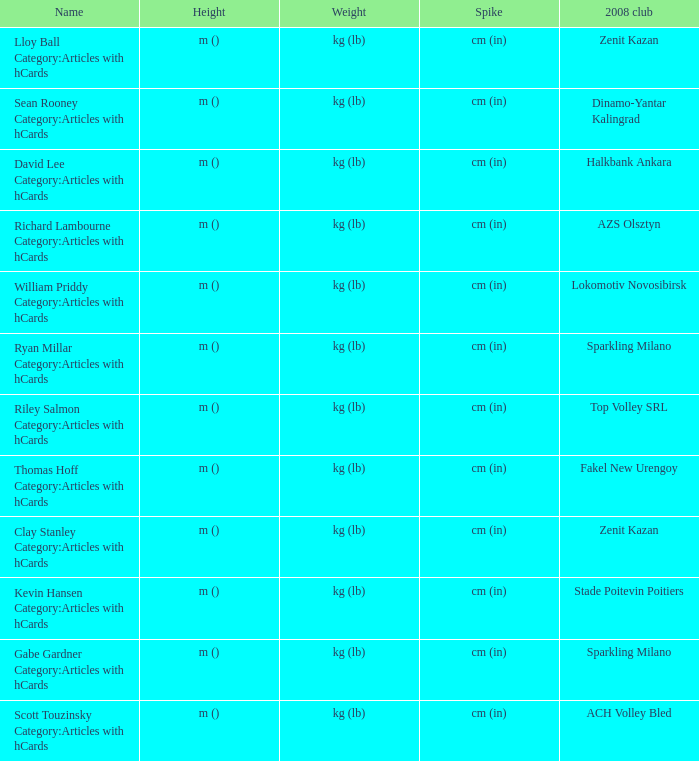What shows for height for the 2008 club of Stade Poitevin Poitiers? M (). 